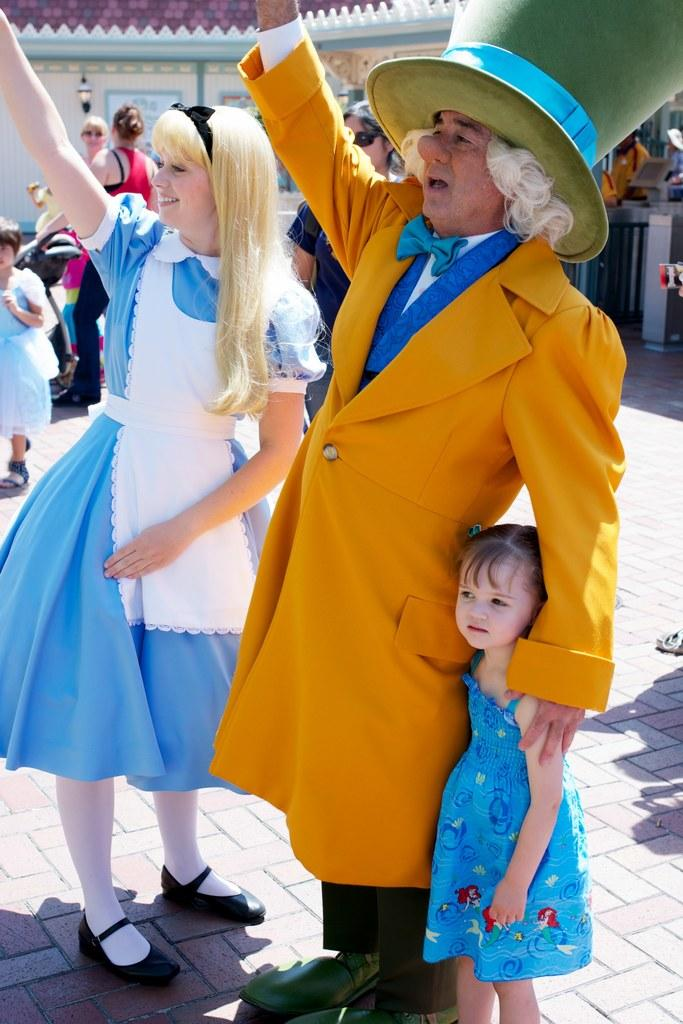How many people are in the image? There is a group of people standing in the image. What can be seen in the background of the image? There is a building in the image. Can you describe any objects present in the image? There are some objects in the image. What caused the spark to ignite in the image? There is no spark present in the image. 